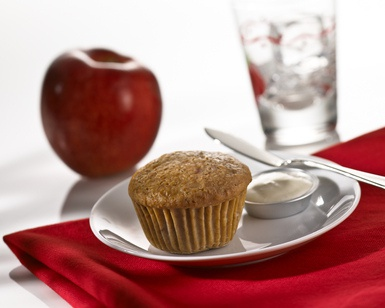Describe the objects in this image and their specific colors. I can see dining table in white, maroon, and gray tones, apple in white, maroon, and lightgray tones, cup in white, darkgray, and gray tones, cake in white, olive, maroon, and gray tones, and knife in white, lightgray, and darkgray tones in this image. 